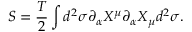Convert formula to latex. <formula><loc_0><loc_0><loc_500><loc_500>S = { \frac { T } { 2 } } \int d ^ { 2 } \sigma \partial _ { \alpha } X ^ { \mu } \partial _ { \alpha } X _ { \mu } d ^ { 2 } \sigma .</formula> 